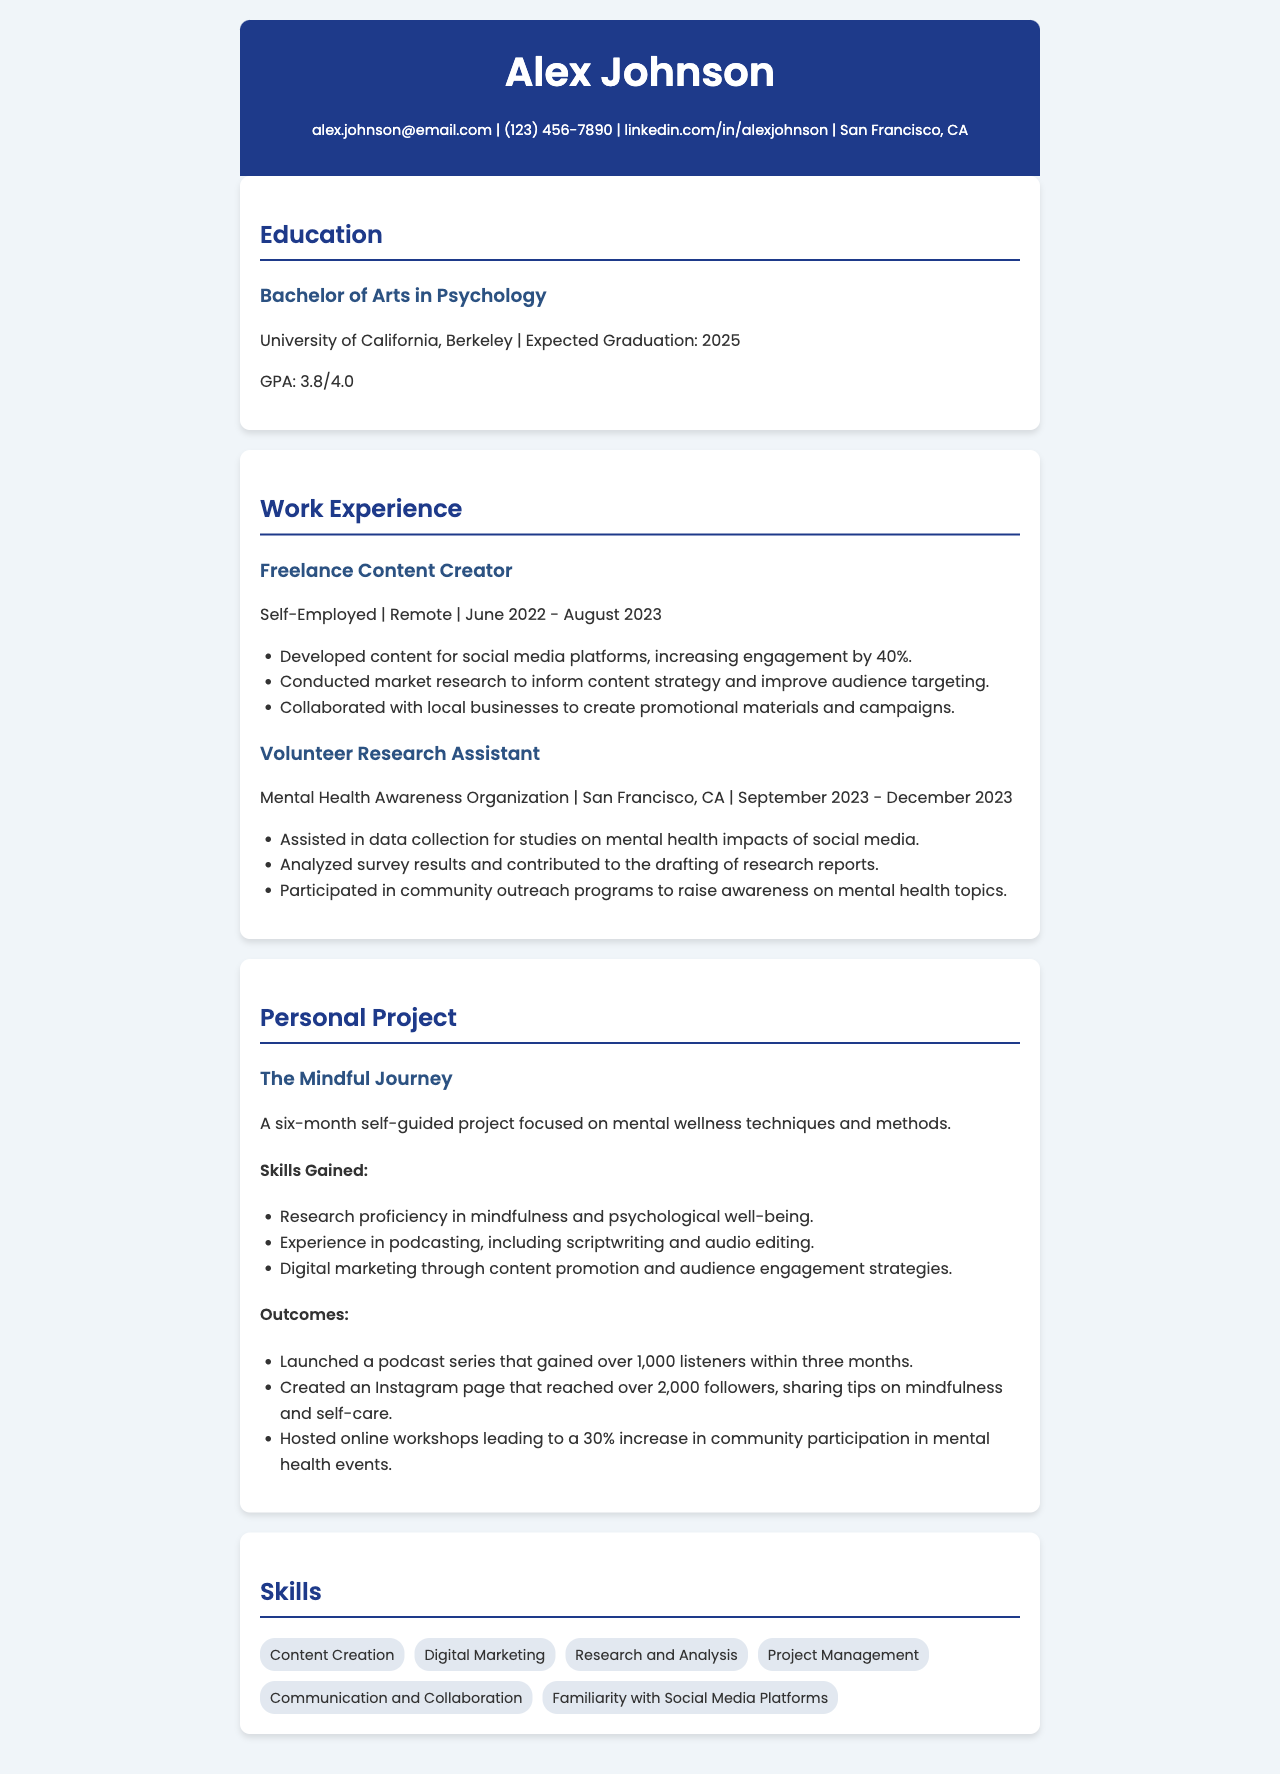what is the expected graduation year? The expected graduation year is stated in the education section of the document.
Answer: 2025 how many listeners did the podcast series gain within three months? The document specifies the number of listeners gained by the podcast series in the outcomes section of the personal project.
Answer: over 1,000 listeners what type of degree is Alex pursuing? The document states the degree program under the education section.
Answer: Bachelor of Arts in Psychology what skill involves creating promotional materials? The document mentions various skills and notes the skills gained specifically associated with the personal project.
Answer: Digital Marketing who is the freelance content creator employed by? The document states the employment type in the work experience section.
Answer: Self-Employed what organization did Alex volunteer for? The organization where Alex volunteered is listed in the work experience section.
Answer: Mental Health Awareness Organization how long did the project "The Mindful Journey" last? The document specifies the duration of the personal project in the personal project section.
Answer: six months which city is Alex based in? The location of Alex is mentioned in the contact information section of the document.
Answer: San Francisco, CA 